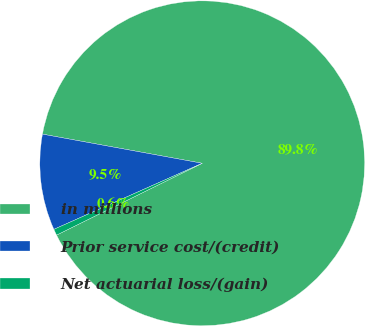Convert chart. <chart><loc_0><loc_0><loc_500><loc_500><pie_chart><fcel>in millions<fcel>Prior service cost/(credit)<fcel>Net actuarial loss/(gain)<nl><fcel>89.84%<fcel>9.54%<fcel>0.62%<nl></chart> 